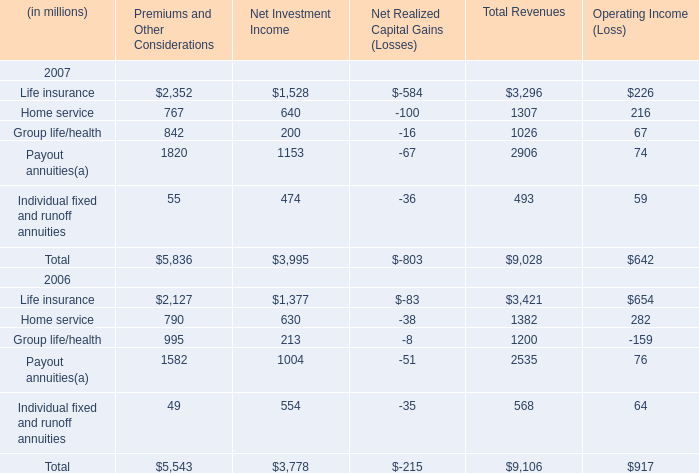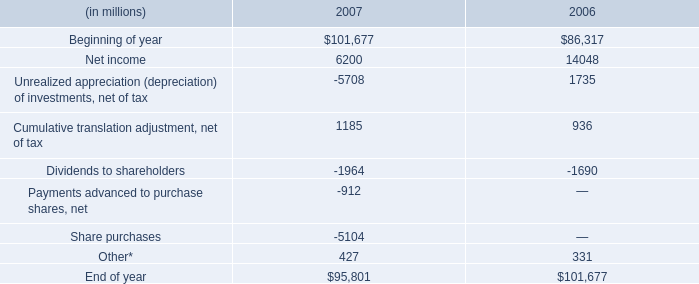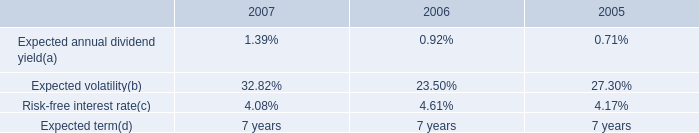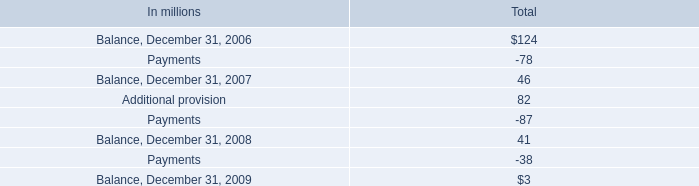What is the average amount of Net income of 2006, and Life insurance of Premiums and Other Considerations ? 
Computations: ((14048.0 + 2352.0) / 2)
Answer: 8200.0. 